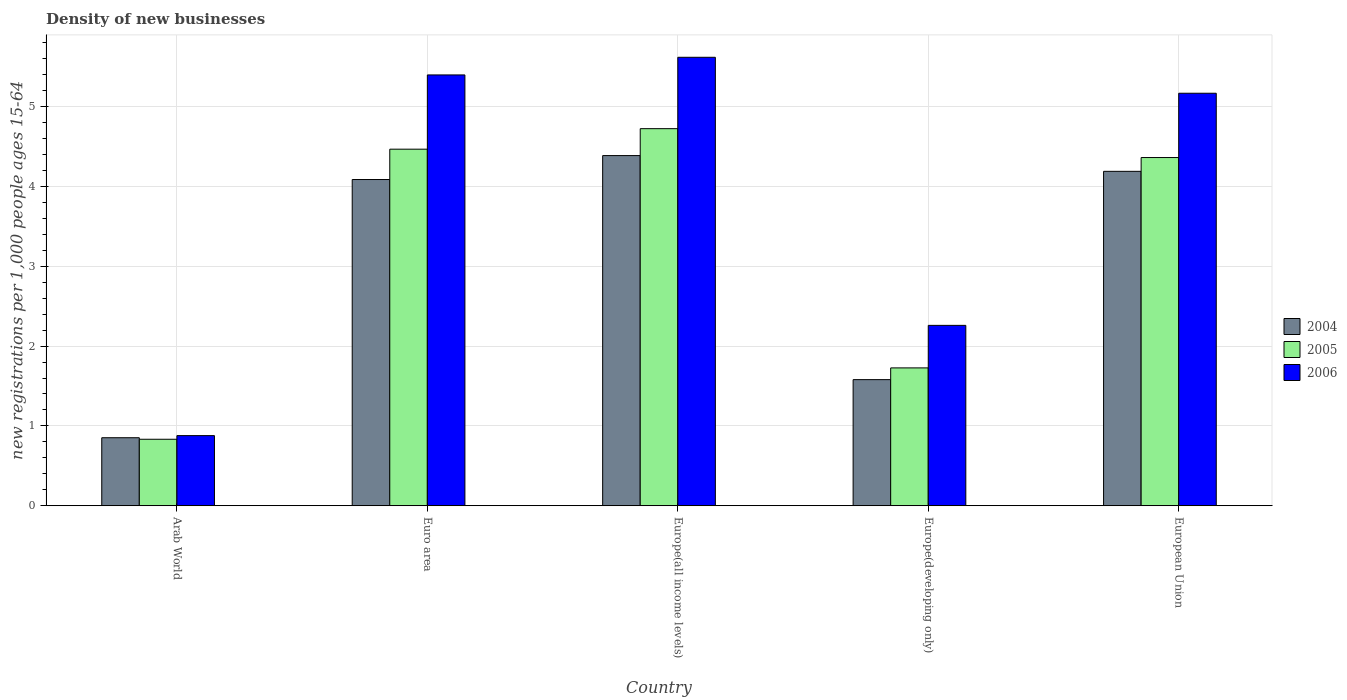Are the number of bars per tick equal to the number of legend labels?
Make the answer very short. Yes. Are the number of bars on each tick of the X-axis equal?
Offer a very short reply. Yes. How many bars are there on the 4th tick from the right?
Make the answer very short. 3. In how many cases, is the number of bars for a given country not equal to the number of legend labels?
Offer a very short reply. 0. What is the number of new registrations in 2005 in Europe(all income levels)?
Give a very brief answer. 4.72. Across all countries, what is the maximum number of new registrations in 2005?
Make the answer very short. 4.72. Across all countries, what is the minimum number of new registrations in 2005?
Provide a succinct answer. 0.83. In which country was the number of new registrations in 2005 maximum?
Ensure brevity in your answer.  Europe(all income levels). In which country was the number of new registrations in 2005 minimum?
Provide a short and direct response. Arab World. What is the total number of new registrations in 2004 in the graph?
Make the answer very short. 15.09. What is the difference between the number of new registrations in 2004 in Europe(all income levels) and that in European Union?
Keep it short and to the point. 0.2. What is the difference between the number of new registrations in 2004 in Europe(developing only) and the number of new registrations in 2006 in European Union?
Ensure brevity in your answer.  -3.59. What is the average number of new registrations in 2004 per country?
Provide a short and direct response. 3.02. What is the difference between the number of new registrations of/in 2006 and number of new registrations of/in 2005 in European Union?
Your response must be concise. 0.81. What is the ratio of the number of new registrations in 2006 in Arab World to that in Europe(all income levels)?
Provide a succinct answer. 0.16. Is the difference between the number of new registrations in 2006 in Euro area and European Union greater than the difference between the number of new registrations in 2005 in Euro area and European Union?
Offer a terse response. Yes. What is the difference between the highest and the second highest number of new registrations in 2005?
Your response must be concise. 0.26. What is the difference between the highest and the lowest number of new registrations in 2006?
Give a very brief answer. 4.74. In how many countries, is the number of new registrations in 2005 greater than the average number of new registrations in 2005 taken over all countries?
Offer a very short reply. 3. Is the sum of the number of new registrations in 2005 in Euro area and European Union greater than the maximum number of new registrations in 2004 across all countries?
Ensure brevity in your answer.  Yes. What does the 3rd bar from the left in Europe(all income levels) represents?
Offer a terse response. 2006. What does the 2nd bar from the right in Euro area represents?
Provide a short and direct response. 2005. Is it the case that in every country, the sum of the number of new registrations in 2006 and number of new registrations in 2004 is greater than the number of new registrations in 2005?
Your answer should be compact. Yes. How many countries are there in the graph?
Give a very brief answer. 5. Where does the legend appear in the graph?
Provide a short and direct response. Center right. How are the legend labels stacked?
Ensure brevity in your answer.  Vertical. What is the title of the graph?
Your answer should be very brief. Density of new businesses. Does "2003" appear as one of the legend labels in the graph?
Offer a terse response. No. What is the label or title of the Y-axis?
Give a very brief answer. New registrations per 1,0 people ages 15-64. What is the new registrations per 1,000 people ages 15-64 in 2004 in Arab World?
Your response must be concise. 0.85. What is the new registrations per 1,000 people ages 15-64 in 2005 in Arab World?
Your answer should be compact. 0.83. What is the new registrations per 1,000 people ages 15-64 in 2006 in Arab World?
Give a very brief answer. 0.88. What is the new registrations per 1,000 people ages 15-64 in 2004 in Euro area?
Your answer should be very brief. 4.09. What is the new registrations per 1,000 people ages 15-64 of 2005 in Euro area?
Provide a succinct answer. 4.47. What is the new registrations per 1,000 people ages 15-64 in 2006 in Euro area?
Give a very brief answer. 5.4. What is the new registrations per 1,000 people ages 15-64 of 2004 in Europe(all income levels)?
Keep it short and to the point. 4.39. What is the new registrations per 1,000 people ages 15-64 of 2005 in Europe(all income levels)?
Give a very brief answer. 4.72. What is the new registrations per 1,000 people ages 15-64 in 2006 in Europe(all income levels)?
Give a very brief answer. 5.62. What is the new registrations per 1,000 people ages 15-64 in 2004 in Europe(developing only)?
Your response must be concise. 1.58. What is the new registrations per 1,000 people ages 15-64 in 2005 in Europe(developing only)?
Keep it short and to the point. 1.73. What is the new registrations per 1,000 people ages 15-64 in 2006 in Europe(developing only)?
Make the answer very short. 2.26. What is the new registrations per 1,000 people ages 15-64 in 2004 in European Union?
Your answer should be compact. 4.19. What is the new registrations per 1,000 people ages 15-64 in 2005 in European Union?
Offer a very short reply. 4.36. What is the new registrations per 1,000 people ages 15-64 in 2006 in European Union?
Your response must be concise. 5.17. Across all countries, what is the maximum new registrations per 1,000 people ages 15-64 in 2004?
Offer a very short reply. 4.39. Across all countries, what is the maximum new registrations per 1,000 people ages 15-64 in 2005?
Keep it short and to the point. 4.72. Across all countries, what is the maximum new registrations per 1,000 people ages 15-64 in 2006?
Give a very brief answer. 5.62. Across all countries, what is the minimum new registrations per 1,000 people ages 15-64 in 2004?
Ensure brevity in your answer.  0.85. Across all countries, what is the minimum new registrations per 1,000 people ages 15-64 in 2005?
Offer a very short reply. 0.83. Across all countries, what is the minimum new registrations per 1,000 people ages 15-64 of 2006?
Provide a short and direct response. 0.88. What is the total new registrations per 1,000 people ages 15-64 of 2004 in the graph?
Provide a succinct answer. 15.09. What is the total new registrations per 1,000 people ages 15-64 in 2005 in the graph?
Give a very brief answer. 16.11. What is the total new registrations per 1,000 people ages 15-64 in 2006 in the graph?
Give a very brief answer. 19.32. What is the difference between the new registrations per 1,000 people ages 15-64 of 2004 in Arab World and that in Euro area?
Provide a succinct answer. -3.23. What is the difference between the new registrations per 1,000 people ages 15-64 of 2005 in Arab World and that in Euro area?
Keep it short and to the point. -3.63. What is the difference between the new registrations per 1,000 people ages 15-64 of 2006 in Arab World and that in Euro area?
Your answer should be very brief. -4.52. What is the difference between the new registrations per 1,000 people ages 15-64 of 2004 in Arab World and that in Europe(all income levels)?
Provide a short and direct response. -3.53. What is the difference between the new registrations per 1,000 people ages 15-64 of 2005 in Arab World and that in Europe(all income levels)?
Make the answer very short. -3.89. What is the difference between the new registrations per 1,000 people ages 15-64 in 2006 in Arab World and that in Europe(all income levels)?
Give a very brief answer. -4.74. What is the difference between the new registrations per 1,000 people ages 15-64 of 2004 in Arab World and that in Europe(developing only)?
Keep it short and to the point. -0.73. What is the difference between the new registrations per 1,000 people ages 15-64 in 2005 in Arab World and that in Europe(developing only)?
Your answer should be compact. -0.89. What is the difference between the new registrations per 1,000 people ages 15-64 in 2006 in Arab World and that in Europe(developing only)?
Offer a very short reply. -1.38. What is the difference between the new registrations per 1,000 people ages 15-64 in 2004 in Arab World and that in European Union?
Provide a short and direct response. -3.34. What is the difference between the new registrations per 1,000 people ages 15-64 in 2005 in Arab World and that in European Union?
Provide a succinct answer. -3.53. What is the difference between the new registrations per 1,000 people ages 15-64 in 2006 in Arab World and that in European Union?
Provide a succinct answer. -4.29. What is the difference between the new registrations per 1,000 people ages 15-64 in 2004 in Euro area and that in Europe(all income levels)?
Offer a very short reply. -0.3. What is the difference between the new registrations per 1,000 people ages 15-64 in 2005 in Euro area and that in Europe(all income levels)?
Offer a terse response. -0.26. What is the difference between the new registrations per 1,000 people ages 15-64 in 2006 in Euro area and that in Europe(all income levels)?
Offer a very short reply. -0.22. What is the difference between the new registrations per 1,000 people ages 15-64 in 2004 in Euro area and that in Europe(developing only)?
Offer a very short reply. 2.51. What is the difference between the new registrations per 1,000 people ages 15-64 in 2005 in Euro area and that in Europe(developing only)?
Provide a succinct answer. 2.74. What is the difference between the new registrations per 1,000 people ages 15-64 of 2006 in Euro area and that in Europe(developing only)?
Provide a short and direct response. 3.14. What is the difference between the new registrations per 1,000 people ages 15-64 in 2004 in Euro area and that in European Union?
Keep it short and to the point. -0.1. What is the difference between the new registrations per 1,000 people ages 15-64 of 2005 in Euro area and that in European Union?
Give a very brief answer. 0.1. What is the difference between the new registrations per 1,000 people ages 15-64 of 2006 in Euro area and that in European Union?
Your answer should be very brief. 0.23. What is the difference between the new registrations per 1,000 people ages 15-64 of 2004 in Europe(all income levels) and that in Europe(developing only)?
Offer a very short reply. 2.81. What is the difference between the new registrations per 1,000 people ages 15-64 in 2005 in Europe(all income levels) and that in Europe(developing only)?
Offer a terse response. 3. What is the difference between the new registrations per 1,000 people ages 15-64 of 2006 in Europe(all income levels) and that in Europe(developing only)?
Offer a very short reply. 3.36. What is the difference between the new registrations per 1,000 people ages 15-64 in 2004 in Europe(all income levels) and that in European Union?
Offer a very short reply. 0.2. What is the difference between the new registrations per 1,000 people ages 15-64 in 2005 in Europe(all income levels) and that in European Union?
Offer a very short reply. 0.36. What is the difference between the new registrations per 1,000 people ages 15-64 of 2006 in Europe(all income levels) and that in European Union?
Your answer should be compact. 0.45. What is the difference between the new registrations per 1,000 people ages 15-64 of 2004 in Europe(developing only) and that in European Union?
Your response must be concise. -2.61. What is the difference between the new registrations per 1,000 people ages 15-64 of 2005 in Europe(developing only) and that in European Union?
Your answer should be very brief. -2.64. What is the difference between the new registrations per 1,000 people ages 15-64 in 2006 in Europe(developing only) and that in European Union?
Offer a terse response. -2.91. What is the difference between the new registrations per 1,000 people ages 15-64 in 2004 in Arab World and the new registrations per 1,000 people ages 15-64 in 2005 in Euro area?
Give a very brief answer. -3.61. What is the difference between the new registrations per 1,000 people ages 15-64 in 2004 in Arab World and the new registrations per 1,000 people ages 15-64 in 2006 in Euro area?
Offer a very short reply. -4.54. What is the difference between the new registrations per 1,000 people ages 15-64 of 2005 in Arab World and the new registrations per 1,000 people ages 15-64 of 2006 in Euro area?
Keep it short and to the point. -4.56. What is the difference between the new registrations per 1,000 people ages 15-64 in 2004 in Arab World and the new registrations per 1,000 people ages 15-64 in 2005 in Europe(all income levels)?
Make the answer very short. -3.87. What is the difference between the new registrations per 1,000 people ages 15-64 of 2004 in Arab World and the new registrations per 1,000 people ages 15-64 of 2006 in Europe(all income levels)?
Make the answer very short. -4.77. What is the difference between the new registrations per 1,000 people ages 15-64 of 2005 in Arab World and the new registrations per 1,000 people ages 15-64 of 2006 in Europe(all income levels)?
Give a very brief answer. -4.79. What is the difference between the new registrations per 1,000 people ages 15-64 in 2004 in Arab World and the new registrations per 1,000 people ages 15-64 in 2005 in Europe(developing only)?
Your response must be concise. -0.87. What is the difference between the new registrations per 1,000 people ages 15-64 of 2004 in Arab World and the new registrations per 1,000 people ages 15-64 of 2006 in Europe(developing only)?
Make the answer very short. -1.41. What is the difference between the new registrations per 1,000 people ages 15-64 in 2005 in Arab World and the new registrations per 1,000 people ages 15-64 in 2006 in Europe(developing only)?
Provide a short and direct response. -1.43. What is the difference between the new registrations per 1,000 people ages 15-64 of 2004 in Arab World and the new registrations per 1,000 people ages 15-64 of 2005 in European Union?
Offer a terse response. -3.51. What is the difference between the new registrations per 1,000 people ages 15-64 of 2004 in Arab World and the new registrations per 1,000 people ages 15-64 of 2006 in European Union?
Give a very brief answer. -4.32. What is the difference between the new registrations per 1,000 people ages 15-64 of 2005 in Arab World and the new registrations per 1,000 people ages 15-64 of 2006 in European Union?
Ensure brevity in your answer.  -4.33. What is the difference between the new registrations per 1,000 people ages 15-64 of 2004 in Euro area and the new registrations per 1,000 people ages 15-64 of 2005 in Europe(all income levels)?
Give a very brief answer. -0.64. What is the difference between the new registrations per 1,000 people ages 15-64 in 2004 in Euro area and the new registrations per 1,000 people ages 15-64 in 2006 in Europe(all income levels)?
Your answer should be very brief. -1.53. What is the difference between the new registrations per 1,000 people ages 15-64 of 2005 in Euro area and the new registrations per 1,000 people ages 15-64 of 2006 in Europe(all income levels)?
Your answer should be very brief. -1.15. What is the difference between the new registrations per 1,000 people ages 15-64 of 2004 in Euro area and the new registrations per 1,000 people ages 15-64 of 2005 in Europe(developing only)?
Your answer should be compact. 2.36. What is the difference between the new registrations per 1,000 people ages 15-64 in 2004 in Euro area and the new registrations per 1,000 people ages 15-64 in 2006 in Europe(developing only)?
Keep it short and to the point. 1.83. What is the difference between the new registrations per 1,000 people ages 15-64 of 2005 in Euro area and the new registrations per 1,000 people ages 15-64 of 2006 in Europe(developing only)?
Offer a very short reply. 2.21. What is the difference between the new registrations per 1,000 people ages 15-64 in 2004 in Euro area and the new registrations per 1,000 people ages 15-64 in 2005 in European Union?
Your answer should be compact. -0.28. What is the difference between the new registrations per 1,000 people ages 15-64 of 2004 in Euro area and the new registrations per 1,000 people ages 15-64 of 2006 in European Union?
Offer a terse response. -1.08. What is the difference between the new registrations per 1,000 people ages 15-64 of 2005 in Euro area and the new registrations per 1,000 people ages 15-64 of 2006 in European Union?
Provide a succinct answer. -0.7. What is the difference between the new registrations per 1,000 people ages 15-64 in 2004 in Europe(all income levels) and the new registrations per 1,000 people ages 15-64 in 2005 in Europe(developing only)?
Your answer should be compact. 2.66. What is the difference between the new registrations per 1,000 people ages 15-64 of 2004 in Europe(all income levels) and the new registrations per 1,000 people ages 15-64 of 2006 in Europe(developing only)?
Provide a short and direct response. 2.13. What is the difference between the new registrations per 1,000 people ages 15-64 of 2005 in Europe(all income levels) and the new registrations per 1,000 people ages 15-64 of 2006 in Europe(developing only)?
Your response must be concise. 2.46. What is the difference between the new registrations per 1,000 people ages 15-64 of 2004 in Europe(all income levels) and the new registrations per 1,000 people ages 15-64 of 2005 in European Union?
Your answer should be compact. 0.02. What is the difference between the new registrations per 1,000 people ages 15-64 of 2004 in Europe(all income levels) and the new registrations per 1,000 people ages 15-64 of 2006 in European Union?
Ensure brevity in your answer.  -0.78. What is the difference between the new registrations per 1,000 people ages 15-64 of 2005 in Europe(all income levels) and the new registrations per 1,000 people ages 15-64 of 2006 in European Union?
Offer a very short reply. -0.44. What is the difference between the new registrations per 1,000 people ages 15-64 in 2004 in Europe(developing only) and the new registrations per 1,000 people ages 15-64 in 2005 in European Union?
Your response must be concise. -2.78. What is the difference between the new registrations per 1,000 people ages 15-64 of 2004 in Europe(developing only) and the new registrations per 1,000 people ages 15-64 of 2006 in European Union?
Offer a very short reply. -3.59. What is the difference between the new registrations per 1,000 people ages 15-64 in 2005 in Europe(developing only) and the new registrations per 1,000 people ages 15-64 in 2006 in European Union?
Give a very brief answer. -3.44. What is the average new registrations per 1,000 people ages 15-64 in 2004 per country?
Keep it short and to the point. 3.02. What is the average new registrations per 1,000 people ages 15-64 in 2005 per country?
Your answer should be compact. 3.22. What is the average new registrations per 1,000 people ages 15-64 in 2006 per country?
Ensure brevity in your answer.  3.86. What is the difference between the new registrations per 1,000 people ages 15-64 in 2004 and new registrations per 1,000 people ages 15-64 in 2005 in Arab World?
Provide a short and direct response. 0.02. What is the difference between the new registrations per 1,000 people ages 15-64 in 2004 and new registrations per 1,000 people ages 15-64 in 2006 in Arab World?
Provide a succinct answer. -0.03. What is the difference between the new registrations per 1,000 people ages 15-64 of 2005 and new registrations per 1,000 people ages 15-64 of 2006 in Arab World?
Provide a short and direct response. -0.05. What is the difference between the new registrations per 1,000 people ages 15-64 of 2004 and new registrations per 1,000 people ages 15-64 of 2005 in Euro area?
Ensure brevity in your answer.  -0.38. What is the difference between the new registrations per 1,000 people ages 15-64 in 2004 and new registrations per 1,000 people ages 15-64 in 2006 in Euro area?
Provide a succinct answer. -1.31. What is the difference between the new registrations per 1,000 people ages 15-64 in 2005 and new registrations per 1,000 people ages 15-64 in 2006 in Euro area?
Give a very brief answer. -0.93. What is the difference between the new registrations per 1,000 people ages 15-64 in 2004 and new registrations per 1,000 people ages 15-64 in 2005 in Europe(all income levels)?
Offer a terse response. -0.34. What is the difference between the new registrations per 1,000 people ages 15-64 in 2004 and new registrations per 1,000 people ages 15-64 in 2006 in Europe(all income levels)?
Your response must be concise. -1.23. What is the difference between the new registrations per 1,000 people ages 15-64 of 2005 and new registrations per 1,000 people ages 15-64 of 2006 in Europe(all income levels)?
Offer a terse response. -0.89. What is the difference between the new registrations per 1,000 people ages 15-64 in 2004 and new registrations per 1,000 people ages 15-64 in 2005 in Europe(developing only)?
Your answer should be compact. -0.15. What is the difference between the new registrations per 1,000 people ages 15-64 of 2004 and new registrations per 1,000 people ages 15-64 of 2006 in Europe(developing only)?
Your answer should be very brief. -0.68. What is the difference between the new registrations per 1,000 people ages 15-64 of 2005 and new registrations per 1,000 people ages 15-64 of 2006 in Europe(developing only)?
Your answer should be compact. -0.53. What is the difference between the new registrations per 1,000 people ages 15-64 in 2004 and new registrations per 1,000 people ages 15-64 in 2005 in European Union?
Give a very brief answer. -0.17. What is the difference between the new registrations per 1,000 people ages 15-64 in 2004 and new registrations per 1,000 people ages 15-64 in 2006 in European Union?
Give a very brief answer. -0.98. What is the difference between the new registrations per 1,000 people ages 15-64 of 2005 and new registrations per 1,000 people ages 15-64 of 2006 in European Union?
Provide a succinct answer. -0.81. What is the ratio of the new registrations per 1,000 people ages 15-64 of 2004 in Arab World to that in Euro area?
Offer a very short reply. 0.21. What is the ratio of the new registrations per 1,000 people ages 15-64 in 2005 in Arab World to that in Euro area?
Your response must be concise. 0.19. What is the ratio of the new registrations per 1,000 people ages 15-64 in 2006 in Arab World to that in Euro area?
Give a very brief answer. 0.16. What is the ratio of the new registrations per 1,000 people ages 15-64 of 2004 in Arab World to that in Europe(all income levels)?
Offer a very short reply. 0.19. What is the ratio of the new registrations per 1,000 people ages 15-64 of 2005 in Arab World to that in Europe(all income levels)?
Your answer should be compact. 0.18. What is the ratio of the new registrations per 1,000 people ages 15-64 in 2006 in Arab World to that in Europe(all income levels)?
Give a very brief answer. 0.16. What is the ratio of the new registrations per 1,000 people ages 15-64 of 2004 in Arab World to that in Europe(developing only)?
Your answer should be compact. 0.54. What is the ratio of the new registrations per 1,000 people ages 15-64 in 2005 in Arab World to that in Europe(developing only)?
Offer a terse response. 0.48. What is the ratio of the new registrations per 1,000 people ages 15-64 of 2006 in Arab World to that in Europe(developing only)?
Ensure brevity in your answer.  0.39. What is the ratio of the new registrations per 1,000 people ages 15-64 in 2004 in Arab World to that in European Union?
Provide a short and direct response. 0.2. What is the ratio of the new registrations per 1,000 people ages 15-64 in 2005 in Arab World to that in European Union?
Give a very brief answer. 0.19. What is the ratio of the new registrations per 1,000 people ages 15-64 in 2006 in Arab World to that in European Union?
Offer a terse response. 0.17. What is the ratio of the new registrations per 1,000 people ages 15-64 in 2004 in Euro area to that in Europe(all income levels)?
Your answer should be compact. 0.93. What is the ratio of the new registrations per 1,000 people ages 15-64 in 2005 in Euro area to that in Europe(all income levels)?
Provide a short and direct response. 0.95. What is the ratio of the new registrations per 1,000 people ages 15-64 of 2006 in Euro area to that in Europe(all income levels)?
Your answer should be compact. 0.96. What is the ratio of the new registrations per 1,000 people ages 15-64 in 2004 in Euro area to that in Europe(developing only)?
Ensure brevity in your answer.  2.59. What is the ratio of the new registrations per 1,000 people ages 15-64 of 2005 in Euro area to that in Europe(developing only)?
Your answer should be compact. 2.59. What is the ratio of the new registrations per 1,000 people ages 15-64 of 2006 in Euro area to that in Europe(developing only)?
Provide a succinct answer. 2.39. What is the ratio of the new registrations per 1,000 people ages 15-64 of 2004 in Euro area to that in European Union?
Your response must be concise. 0.98. What is the ratio of the new registrations per 1,000 people ages 15-64 in 2006 in Euro area to that in European Union?
Your response must be concise. 1.04. What is the ratio of the new registrations per 1,000 people ages 15-64 of 2004 in Europe(all income levels) to that in Europe(developing only)?
Offer a terse response. 2.78. What is the ratio of the new registrations per 1,000 people ages 15-64 of 2005 in Europe(all income levels) to that in Europe(developing only)?
Keep it short and to the point. 2.74. What is the ratio of the new registrations per 1,000 people ages 15-64 of 2006 in Europe(all income levels) to that in Europe(developing only)?
Your response must be concise. 2.49. What is the ratio of the new registrations per 1,000 people ages 15-64 in 2004 in Europe(all income levels) to that in European Union?
Offer a terse response. 1.05. What is the ratio of the new registrations per 1,000 people ages 15-64 of 2005 in Europe(all income levels) to that in European Union?
Offer a very short reply. 1.08. What is the ratio of the new registrations per 1,000 people ages 15-64 in 2006 in Europe(all income levels) to that in European Union?
Provide a short and direct response. 1.09. What is the ratio of the new registrations per 1,000 people ages 15-64 of 2004 in Europe(developing only) to that in European Union?
Ensure brevity in your answer.  0.38. What is the ratio of the new registrations per 1,000 people ages 15-64 of 2005 in Europe(developing only) to that in European Union?
Ensure brevity in your answer.  0.4. What is the ratio of the new registrations per 1,000 people ages 15-64 of 2006 in Europe(developing only) to that in European Union?
Give a very brief answer. 0.44. What is the difference between the highest and the second highest new registrations per 1,000 people ages 15-64 in 2004?
Give a very brief answer. 0.2. What is the difference between the highest and the second highest new registrations per 1,000 people ages 15-64 in 2005?
Provide a succinct answer. 0.26. What is the difference between the highest and the second highest new registrations per 1,000 people ages 15-64 of 2006?
Your response must be concise. 0.22. What is the difference between the highest and the lowest new registrations per 1,000 people ages 15-64 in 2004?
Provide a short and direct response. 3.53. What is the difference between the highest and the lowest new registrations per 1,000 people ages 15-64 in 2005?
Offer a terse response. 3.89. What is the difference between the highest and the lowest new registrations per 1,000 people ages 15-64 in 2006?
Keep it short and to the point. 4.74. 